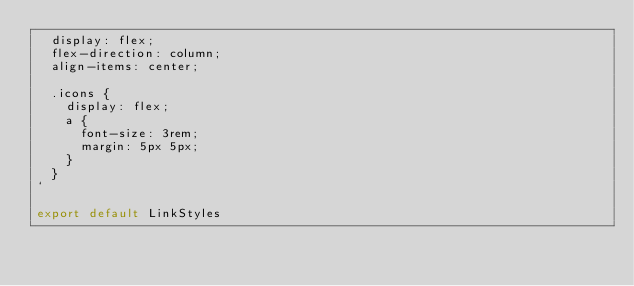<code> <loc_0><loc_0><loc_500><loc_500><_JavaScript_>  display: flex;
  flex-direction: column;
  align-items: center;

  .icons {
    display: flex;
    a {
      font-size: 3rem;
      margin: 5px 5px;
    }
  }
`

export default LinkStyles
</code> 